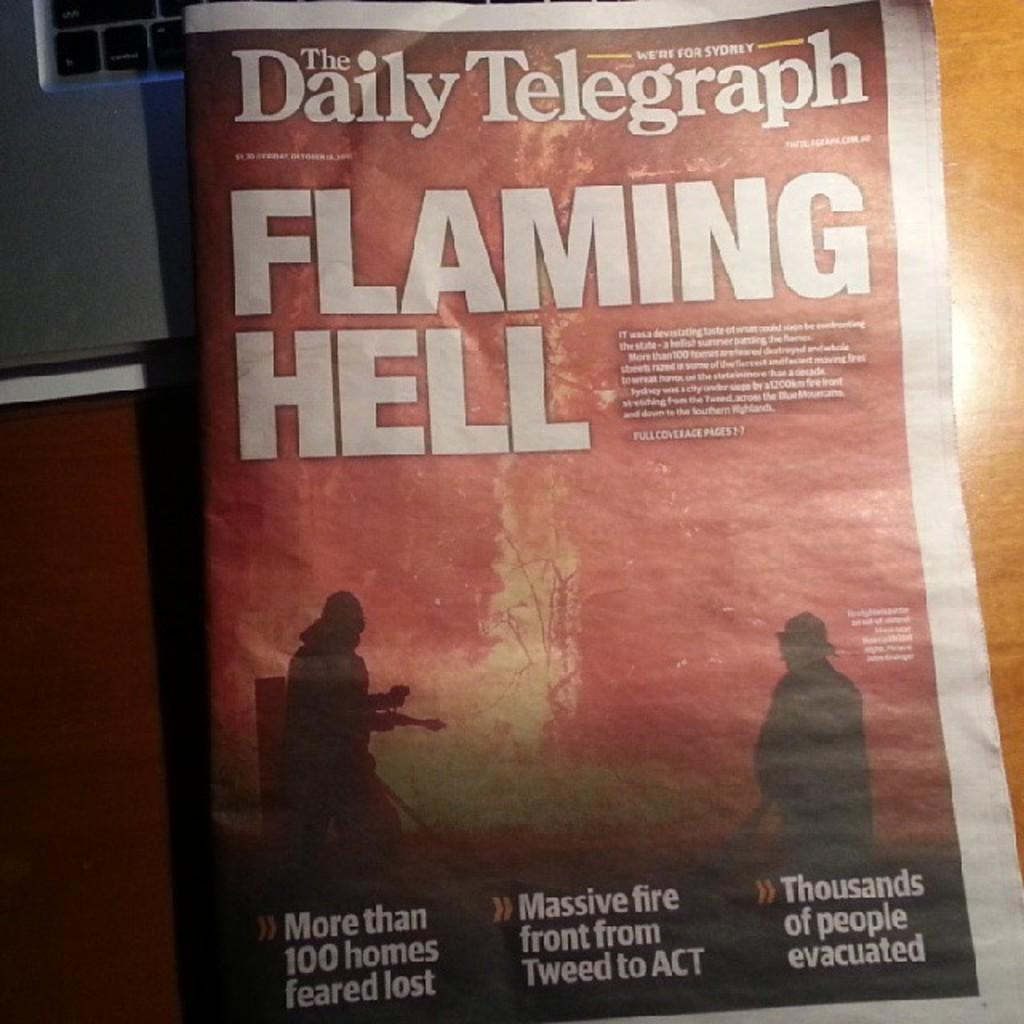<image>
Share a concise interpretation of the image provided. a newspaper with Flaming Hell written in it 